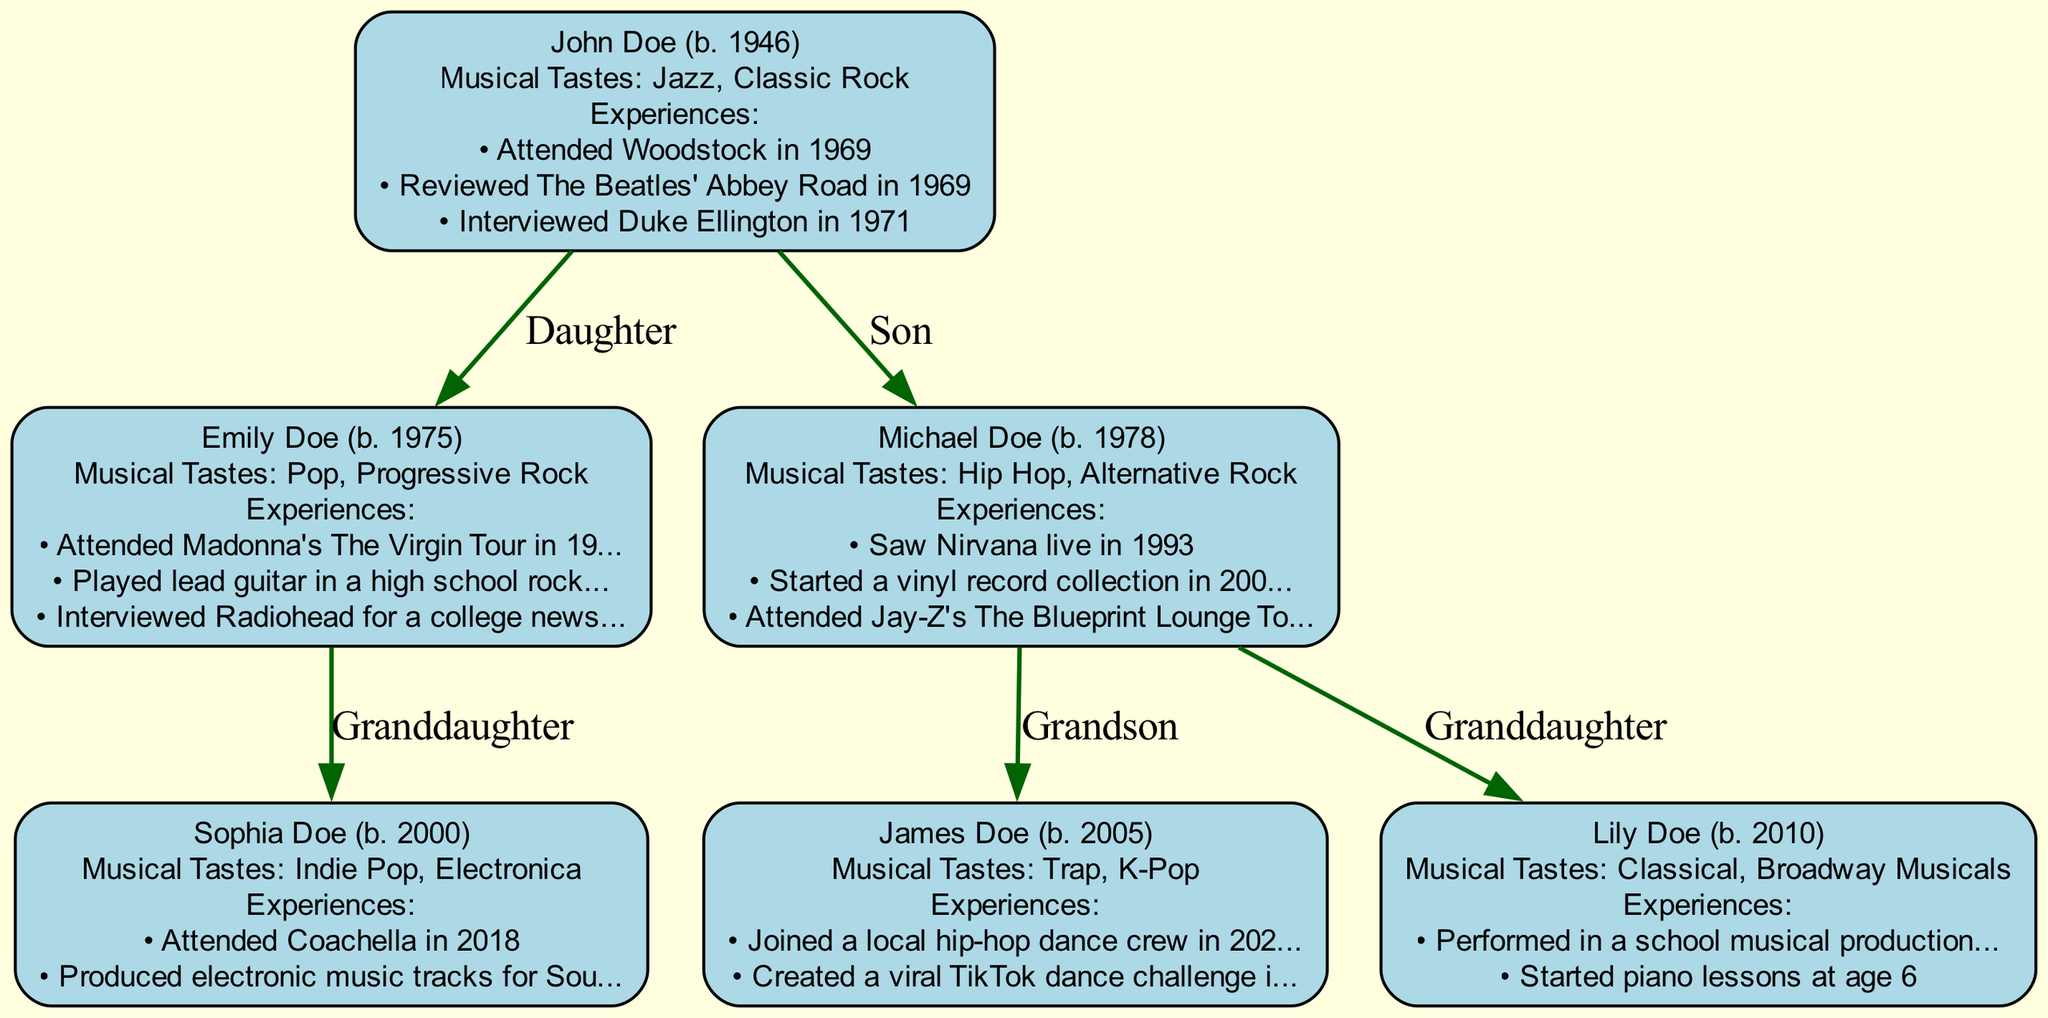What is the birth year of John Doe? Looking at the root node labeled "John Doe," we can see the birth year mentioned as "1946."
Answer: 1946 How many children does John Doe have? John Doe has two children listed under the "children" key: "Emily Doe" and "Michael Doe." Therefore, that total count is two.
Answer: 2 What are Emily Doe's musical tastes? The label for Emily Doe lists her musical tastes as "Pop" and "Progressive Rock."
Answer: Pop, Progressive Rock What significant experience did Michael Doe have in 2000? In examining Michael Doe's list of significant experiences, we find "Started a vinyl record collection in 2000" noted.
Answer: Started a vinyl record collection How many grandchildren does Michael Doe have? Michael Doe has two listed grandchildren: "James Doe" and "Lily Doe," located under his children section. Thus, the count is two.
Answer: 2 What genres of music does Sophia Doe prefer? Sophia Doe's musical tastes are categorized as "Indie Pop" and "Electronica," found under her node.
Answer: Indie Pop, Electronica What notable event did John Doe attend in 1969? Among his significant experiences, John Doe attended "Woodstock in 1969," which is explicitly mentioned in his experiences.
Answer: Woodstock Which grandson of John Doe participated in a hip-hop dance crew? James Doe, identified in the grandchildren section of Michael Doe, has the experience of joining "a local hip-hop dance crew in 2022."
Answer: James Doe What is Michael Doe’s relationship to John Doe? The diagram's structure indicates that Michael Doe is a "Son," which is stated as the relationship attached to his node.
Answer: Son How many significant experiences does Lily Doe have listed? Lily Doe's node states she has two significant experiences provided in her profile, counted directly from her section.
Answer: 2 